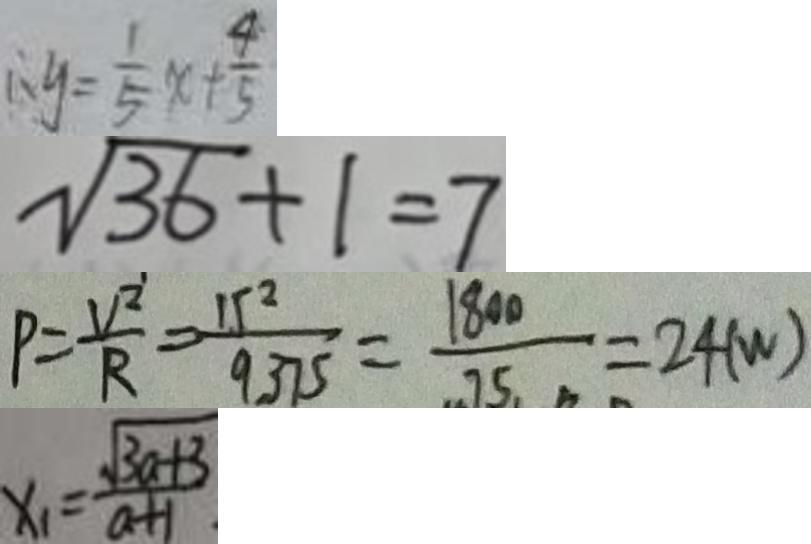Convert formula to latex. <formula><loc_0><loc_0><loc_500><loc_500>\therefore y = \frac { 1 } { 5 } x + \frac { 4 } { 5 } 
 \sqrt { 3 6 } + 1 = 7 
 P = \frac { V ^ { 2 } } { R } = \frac { 1 5 ^ { 2 } } { 9 3 7 5 } = \frac { 1 8 0 0 } { 7 5 } = 2 4 ( w ) 
 x _ { 1 } = \frac { \sqrt { 3 a + 3 } } { a + 1 }</formula> 